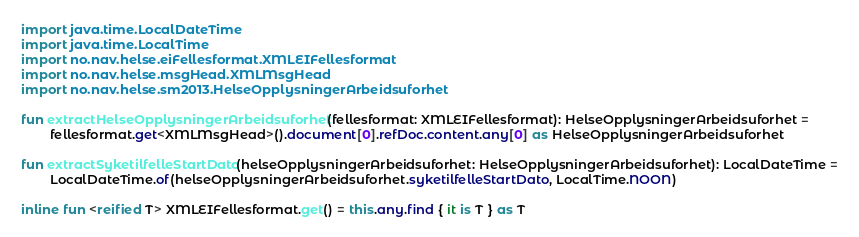<code> <loc_0><loc_0><loc_500><loc_500><_Kotlin_>import java.time.LocalDateTime
import java.time.LocalTime
import no.nav.helse.eiFellesformat.XMLEIFellesformat
import no.nav.helse.msgHead.XMLMsgHead
import no.nav.helse.sm2013.HelseOpplysningerArbeidsuforhet

fun extractHelseOpplysningerArbeidsuforhet(fellesformat: XMLEIFellesformat): HelseOpplysningerArbeidsuforhet =
        fellesformat.get<XMLMsgHead>().document[0].refDoc.content.any[0] as HelseOpplysningerArbeidsuforhet

fun extractSyketilfelleStartDato(helseOpplysningerArbeidsuforhet: HelseOpplysningerArbeidsuforhet): LocalDateTime =
        LocalDateTime.of(helseOpplysningerArbeidsuforhet.syketilfelleStartDato, LocalTime.NOON)

inline fun <reified T> XMLEIFellesformat.get() = this.any.find { it is T } as T
</code> 